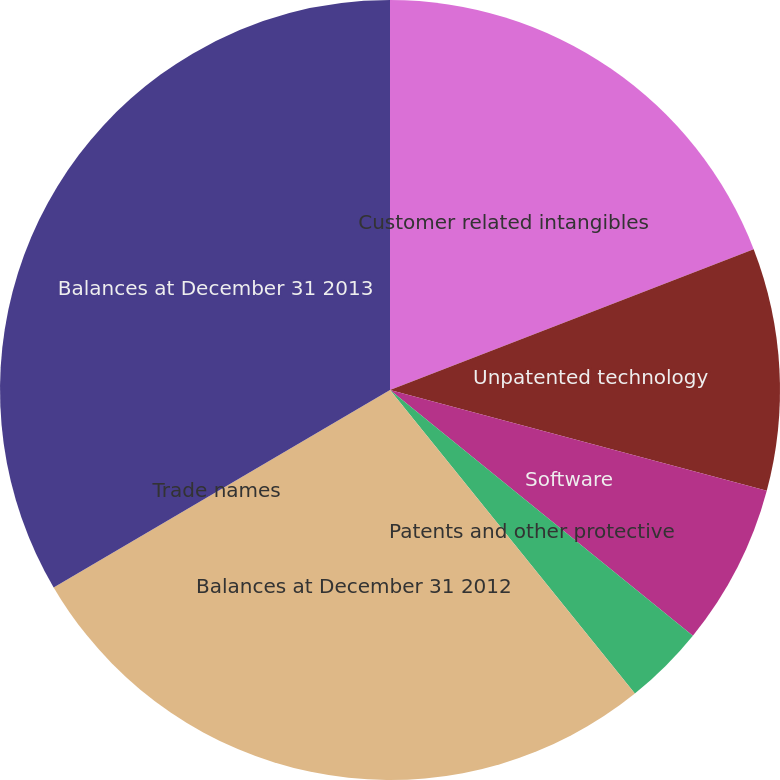<chart> <loc_0><loc_0><loc_500><loc_500><pie_chart><fcel>Customer related intangibles<fcel>Unpatented technology<fcel>Software<fcel>Patents and other protective<fcel>Balances at December 31 2012<fcel>Trade names<fcel>Balances at December 31 2013<nl><fcel>19.12%<fcel>10.04%<fcel>6.69%<fcel>3.35%<fcel>27.36%<fcel>0.0%<fcel>33.45%<nl></chart> 